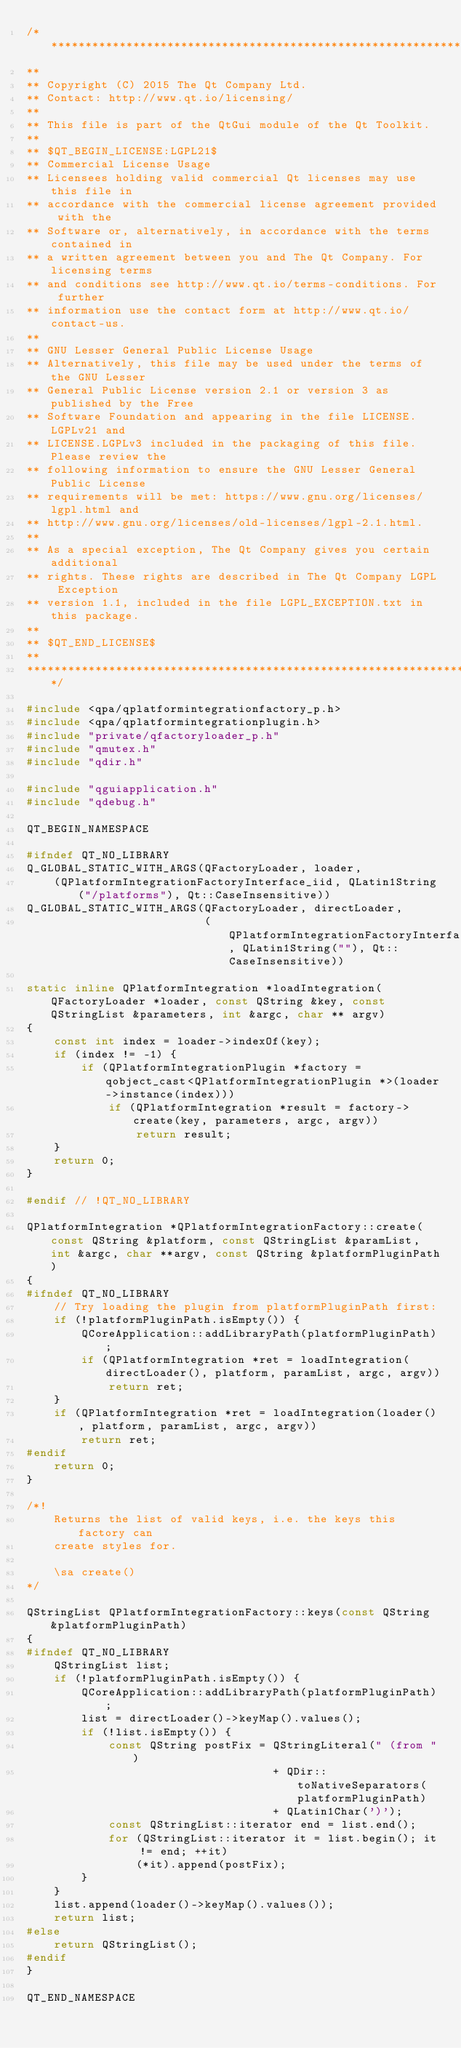<code> <loc_0><loc_0><loc_500><loc_500><_C++_>/****************************************************************************
**
** Copyright (C) 2015 The Qt Company Ltd.
** Contact: http://www.qt.io/licensing/
**
** This file is part of the QtGui module of the Qt Toolkit.
**
** $QT_BEGIN_LICENSE:LGPL21$
** Commercial License Usage
** Licensees holding valid commercial Qt licenses may use this file in
** accordance with the commercial license agreement provided with the
** Software or, alternatively, in accordance with the terms contained in
** a written agreement between you and The Qt Company. For licensing terms
** and conditions see http://www.qt.io/terms-conditions. For further
** information use the contact form at http://www.qt.io/contact-us.
**
** GNU Lesser General Public License Usage
** Alternatively, this file may be used under the terms of the GNU Lesser
** General Public License version 2.1 or version 3 as published by the Free
** Software Foundation and appearing in the file LICENSE.LGPLv21 and
** LICENSE.LGPLv3 included in the packaging of this file. Please review the
** following information to ensure the GNU Lesser General Public License
** requirements will be met: https://www.gnu.org/licenses/lgpl.html and
** http://www.gnu.org/licenses/old-licenses/lgpl-2.1.html.
**
** As a special exception, The Qt Company gives you certain additional
** rights. These rights are described in The Qt Company LGPL Exception
** version 1.1, included in the file LGPL_EXCEPTION.txt in this package.
**
** $QT_END_LICENSE$
**
****************************************************************************/

#include <qpa/qplatformintegrationfactory_p.h>
#include <qpa/qplatformintegrationplugin.h>
#include "private/qfactoryloader_p.h"
#include "qmutex.h"
#include "qdir.h"

#include "qguiapplication.h"
#include "qdebug.h"

QT_BEGIN_NAMESPACE

#ifndef QT_NO_LIBRARY
Q_GLOBAL_STATIC_WITH_ARGS(QFactoryLoader, loader,
    (QPlatformIntegrationFactoryInterface_iid, QLatin1String("/platforms"), Qt::CaseInsensitive))
Q_GLOBAL_STATIC_WITH_ARGS(QFactoryLoader, directLoader,
                          (QPlatformIntegrationFactoryInterface_iid, QLatin1String(""), Qt::CaseInsensitive))

static inline QPlatformIntegration *loadIntegration(QFactoryLoader *loader, const QString &key, const QStringList &parameters, int &argc, char ** argv)
{
    const int index = loader->indexOf(key);
    if (index != -1) {
        if (QPlatformIntegrationPlugin *factory = qobject_cast<QPlatformIntegrationPlugin *>(loader->instance(index)))
            if (QPlatformIntegration *result = factory->create(key, parameters, argc, argv))
                return result;
    }
    return 0;
}

#endif // !QT_NO_LIBRARY

QPlatformIntegration *QPlatformIntegrationFactory::create(const QString &platform, const QStringList &paramList, int &argc, char **argv, const QString &platformPluginPath)
{
#ifndef QT_NO_LIBRARY
    // Try loading the plugin from platformPluginPath first:
    if (!platformPluginPath.isEmpty()) {
        QCoreApplication::addLibraryPath(platformPluginPath);
        if (QPlatformIntegration *ret = loadIntegration(directLoader(), platform, paramList, argc, argv))
            return ret;
    }
    if (QPlatformIntegration *ret = loadIntegration(loader(), platform, paramList, argc, argv))
        return ret;
#endif
    return 0;
}

/*!
    Returns the list of valid keys, i.e. the keys this factory can
    create styles for.

    \sa create()
*/

QStringList QPlatformIntegrationFactory::keys(const QString &platformPluginPath)
{
#ifndef QT_NO_LIBRARY
    QStringList list;
    if (!platformPluginPath.isEmpty()) {
        QCoreApplication::addLibraryPath(platformPluginPath);
        list = directLoader()->keyMap().values();
        if (!list.isEmpty()) {
            const QString postFix = QStringLiteral(" (from ")
                                    + QDir::toNativeSeparators(platformPluginPath)
                                    + QLatin1Char(')');
            const QStringList::iterator end = list.end();
            for (QStringList::iterator it = list.begin(); it != end; ++it)
                (*it).append(postFix);
        }
    }
    list.append(loader()->keyMap().values());
    return list;
#else
    return QStringList();
#endif
}

QT_END_NAMESPACE

</code> 